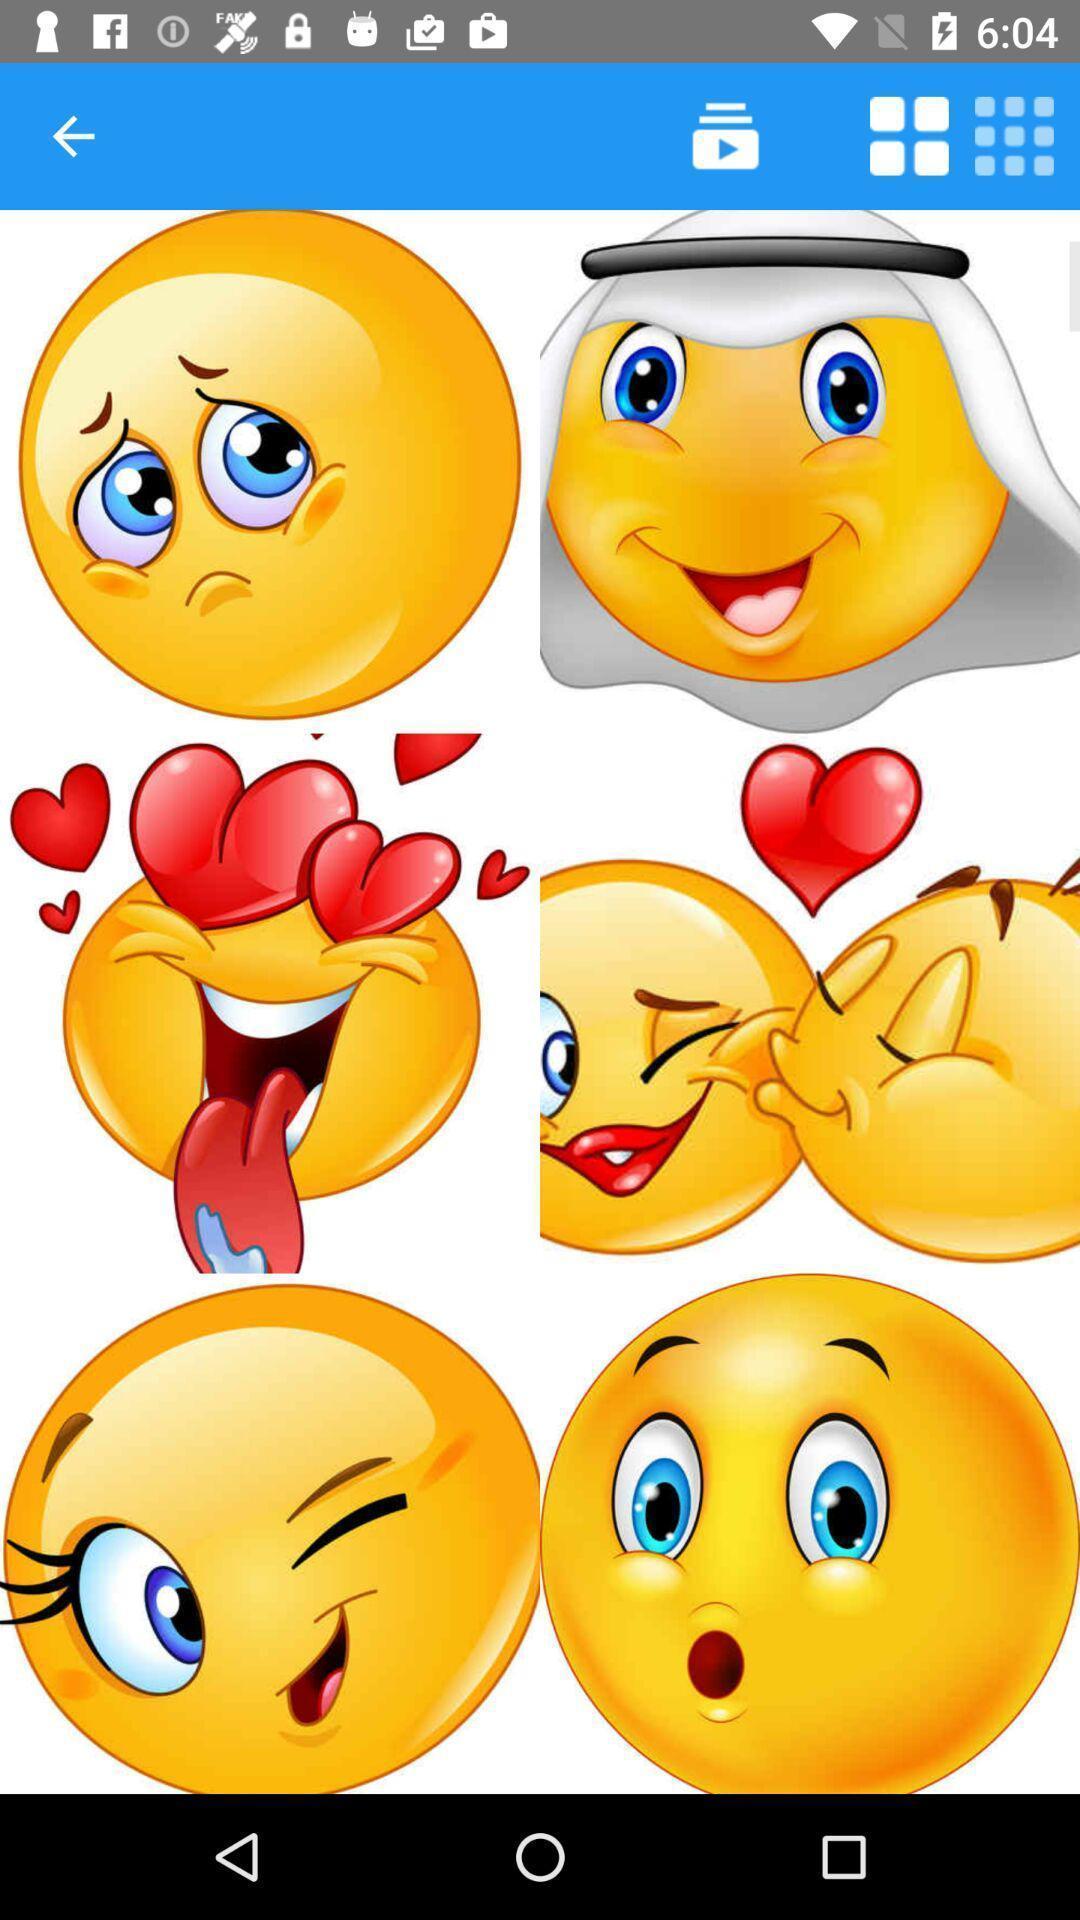Explain what's happening in this screen capture. Window displaying different emojis for app. 